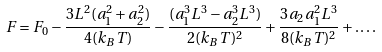<formula> <loc_0><loc_0><loc_500><loc_500>F = F _ { 0 } - \frac { 3 L ^ { 2 } ( a _ { 1 } ^ { 2 } + a _ { 2 } ^ { 2 } ) } { 4 ( k _ { B } T ) } - \frac { ( a _ { 1 } ^ { 3 } L ^ { 3 } - a _ { 2 } ^ { 3 } L ^ { 3 } ) } { 2 ( k _ { B } T ) ^ { 2 } } + \frac { 3 a _ { 2 } a _ { 1 } ^ { 2 } L ^ { 3 } } { 8 ( k _ { B } T ) ^ { 2 } } + \dots .</formula> 